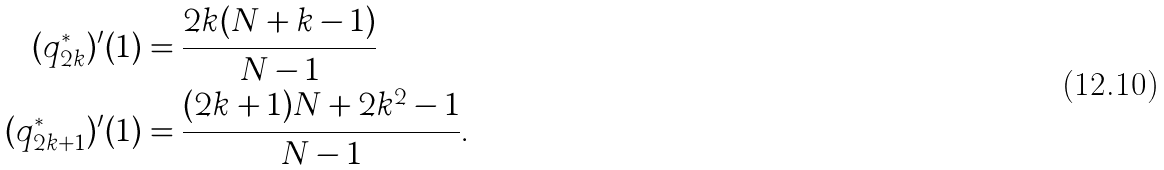Convert formula to latex. <formula><loc_0><loc_0><loc_500><loc_500>( q _ { 2 k } ^ { * } ) ^ { \prime } ( 1 ) & = \frac { 2 k ( N + k - 1 ) } { N - 1 } \\ ( q _ { 2 k + 1 } ^ { * } ) ^ { \prime } ( 1 ) & = \frac { ( 2 k + 1 ) N + 2 k ^ { 2 } - 1 } { N - 1 } .</formula> 